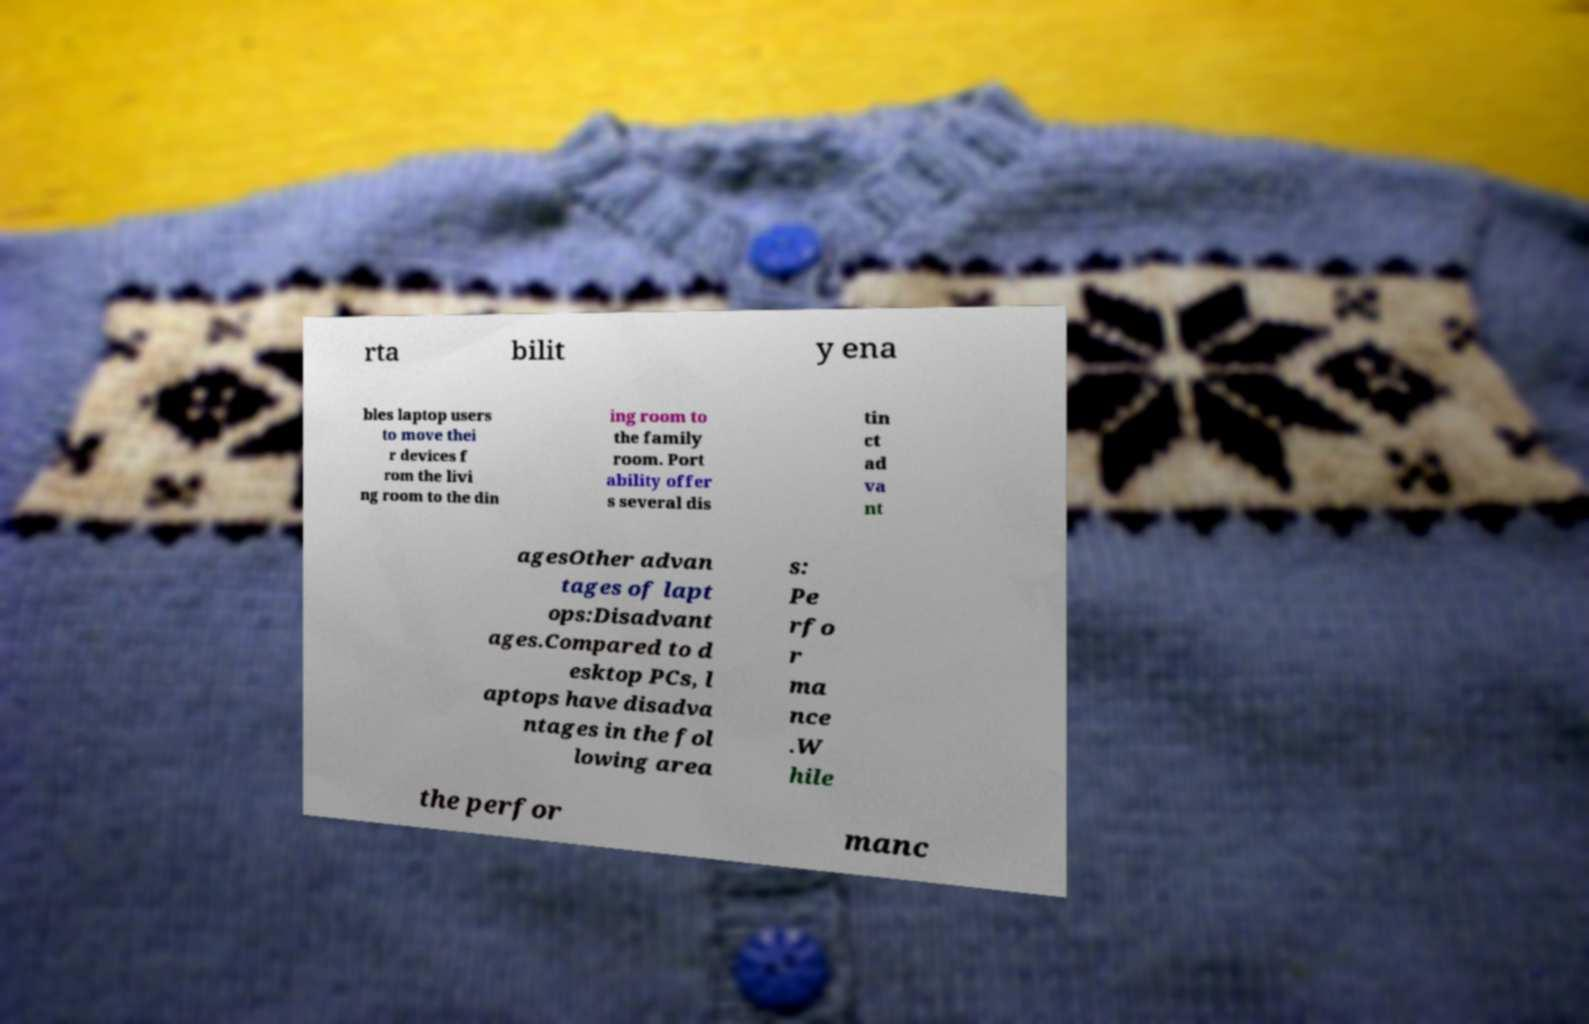Please identify and transcribe the text found in this image. rta bilit y ena bles laptop users to move thei r devices f rom the livi ng room to the din ing room to the family room. Port ability offer s several dis tin ct ad va nt agesOther advan tages of lapt ops:Disadvant ages.Compared to d esktop PCs, l aptops have disadva ntages in the fol lowing area s: Pe rfo r ma nce .W hile the perfor manc 